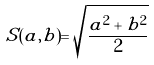<formula> <loc_0><loc_0><loc_500><loc_500>S ( a , b ) = \sqrt { \frac { a ^ { 2 } + b ^ { 2 } } { 2 } }</formula> 